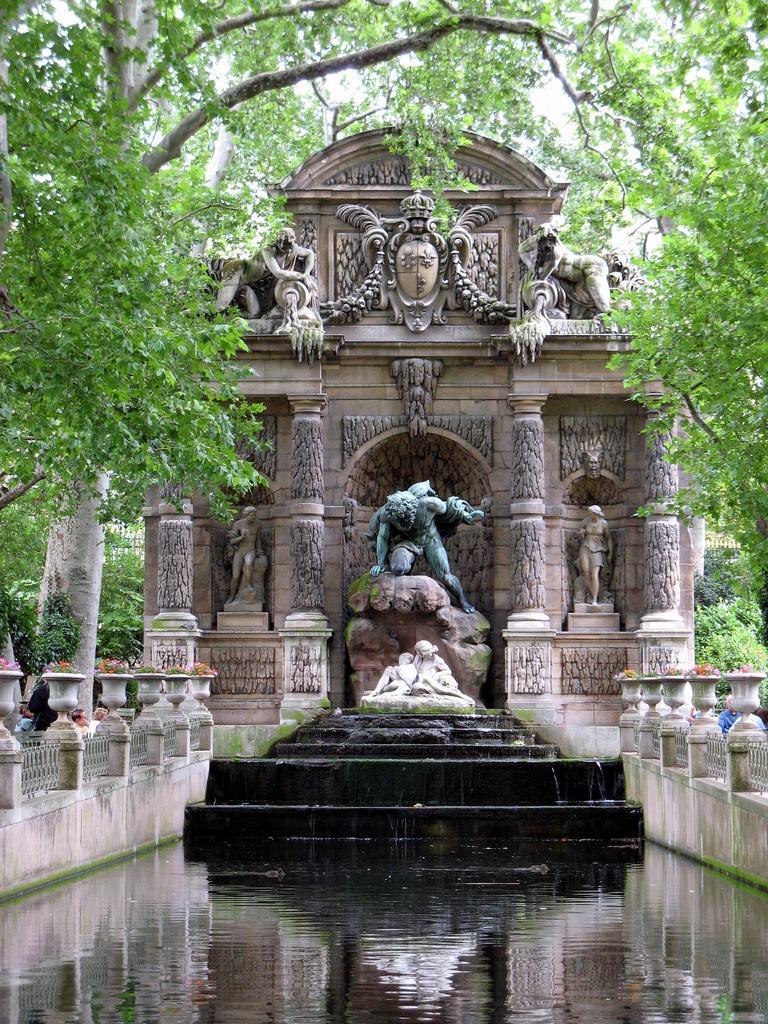Could you give a brief overview of what you see in this image? In the center of the image we can see the statue, water fountain and also the sculptures on the wall. We can also see the trees, people, flower pots. 